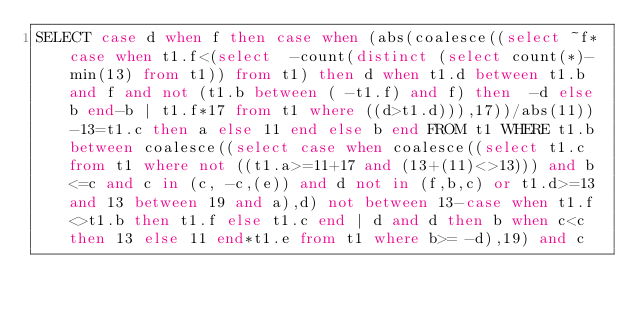Convert code to text. <code><loc_0><loc_0><loc_500><loc_500><_SQL_>SELECT case d when f then case when (abs(coalesce((select ~f*case when t1.f<(select  -count(distinct (select count(*)-min(13) from t1)) from t1) then d when t1.d between t1.b and f and not (t1.b between ( -t1.f) and f) then  -d else b end-b | t1.f*17 from t1 where ((d>t1.d))),17))/abs(11))-13=t1.c then a else 11 end else b end FROM t1 WHERE t1.b between coalesce((select case when coalesce((select t1.c from t1 where not ((t1.a>=11+17 and (13+(11)<>13))) and b<=c and c in (c, -c,(e)) and d not in (f,b,c) or t1.d>=13 and 13 between 19 and a),d) not between 13-case when t1.f<>t1.b then t1.f else t1.c end | d and d then b when c<c then 13 else 11 end*t1.e from t1 where b>= -d),19) and c</code> 